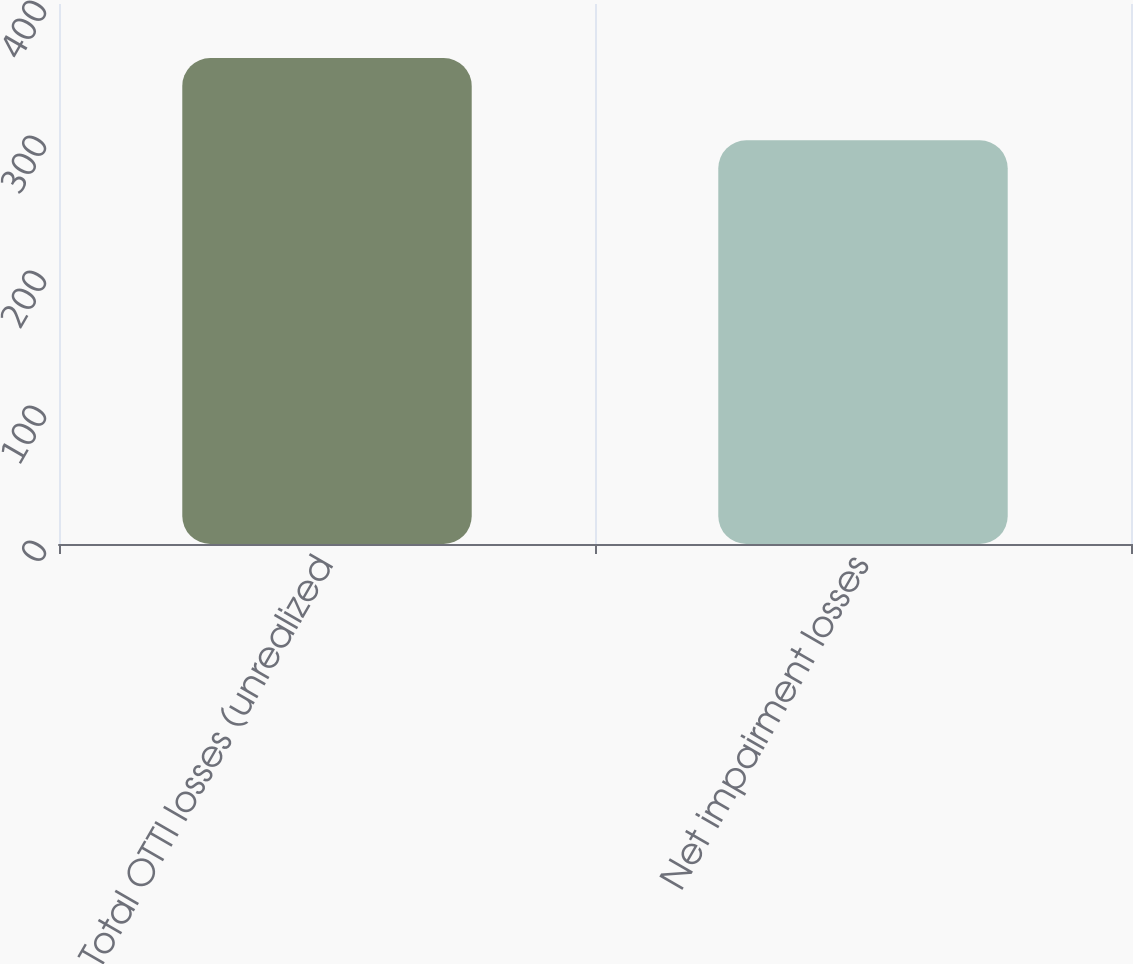Convert chart to OTSL. <chart><loc_0><loc_0><loc_500><loc_500><bar_chart><fcel>Total OTTI losses (unrealized<fcel>Net impairment losses<nl><fcel>360<fcel>299<nl></chart> 